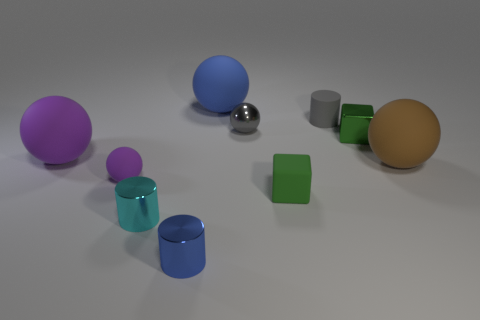How many green shiny things have the same size as the gray matte cylinder?
Ensure brevity in your answer.  1. Is the number of tiny cyan metallic cylinders on the left side of the big purple rubber ball the same as the number of tiny red matte blocks?
Offer a terse response. Yes. What number of objects are both left of the tiny blue metallic thing and in front of the brown matte thing?
Keep it short and to the point. 2. There is a gray thing in front of the small gray matte thing; is its shape the same as the small gray matte object?
Offer a very short reply. No. There is a purple ball that is the same size as the brown ball; what material is it?
Your response must be concise. Rubber. Are there an equal number of metallic objects that are behind the large purple thing and brown things behind the small gray cylinder?
Provide a succinct answer. No. There is a tiny sphere that is to the right of the blue cylinder that is in front of the tiny purple rubber object; what number of small metallic cylinders are in front of it?
Keep it short and to the point. 2. Is the color of the small matte ball the same as the thing in front of the cyan shiny thing?
Ensure brevity in your answer.  No. The green block that is made of the same material as the big brown object is what size?
Make the answer very short. Small. Are there more tiny gray matte things that are in front of the blue cylinder than tiny rubber balls?
Give a very brief answer. No. 